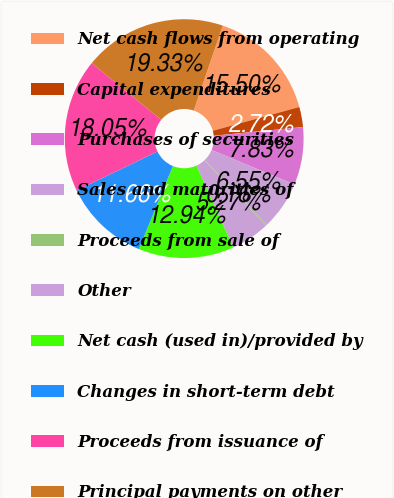<chart> <loc_0><loc_0><loc_500><loc_500><pie_chart><fcel>Net cash flows from operating<fcel>Capital expenditures<fcel>Purchases of securities<fcel>Sales and maturities of<fcel>Proceeds from sale of<fcel>Other<fcel>Net cash (used in)/provided by<fcel>Changes in short-term debt<fcel>Proceeds from issuance of<fcel>Principal payments on other<nl><fcel>15.5%<fcel>2.72%<fcel>7.83%<fcel>6.55%<fcel>0.16%<fcel>5.27%<fcel>12.94%<fcel>11.66%<fcel>18.05%<fcel>19.33%<nl></chart> 